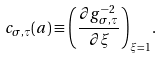Convert formula to latex. <formula><loc_0><loc_0><loc_500><loc_500>c _ { \sigma , \tau } ( a ) \equiv \left ( \frac { \partial g ^ { - 2 } _ { \sigma , \tau } } { \partial \xi } \right ) _ { \xi = 1 } .</formula> 